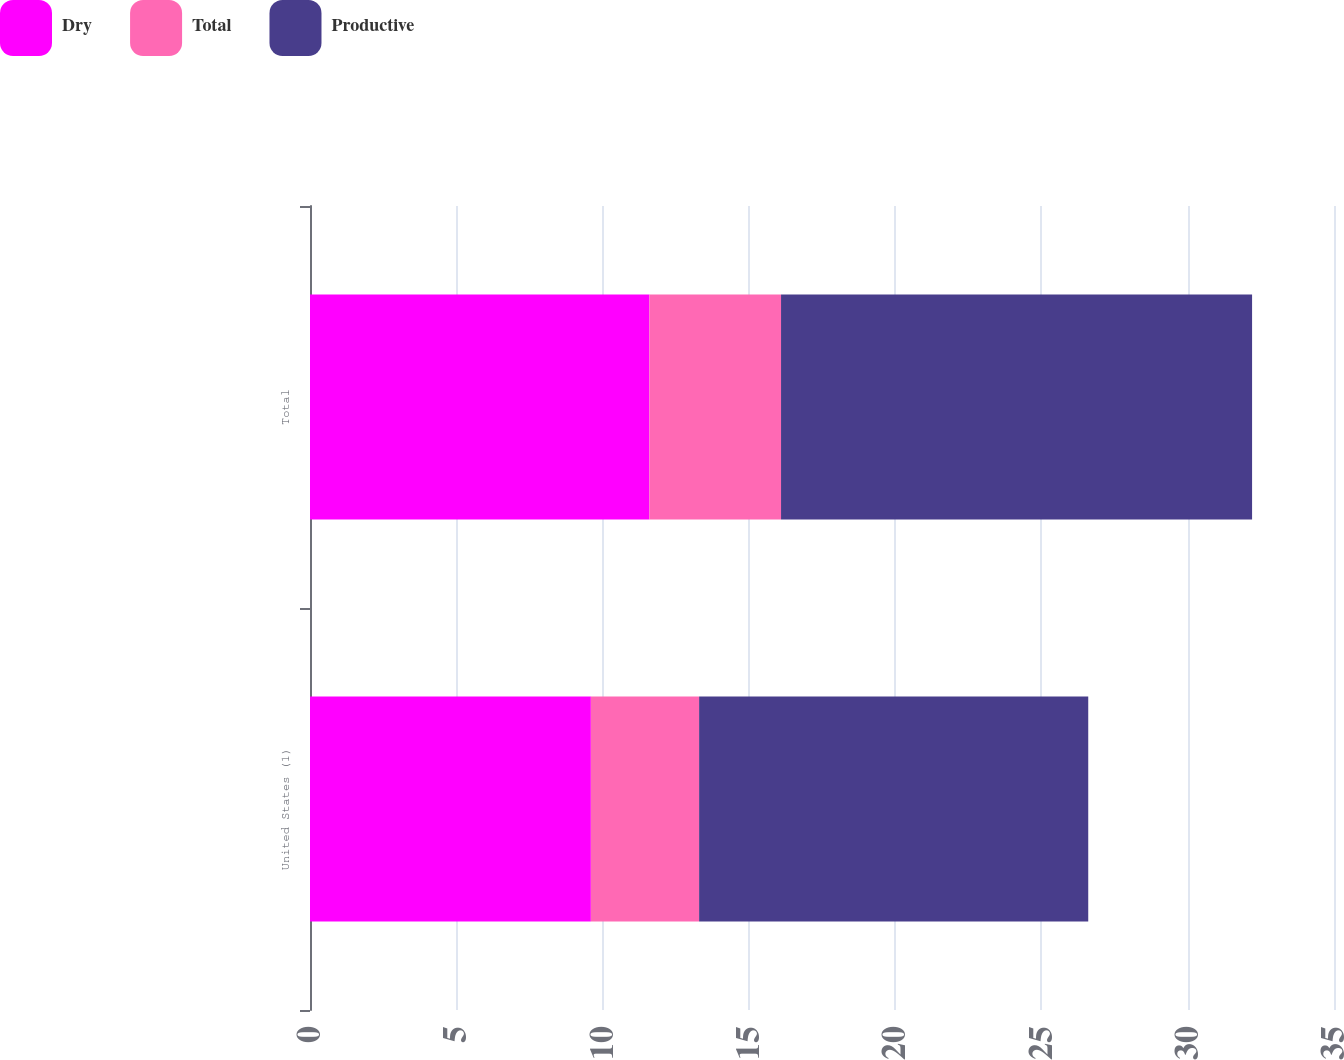Convert chart to OTSL. <chart><loc_0><loc_0><loc_500><loc_500><stacked_bar_chart><ecel><fcel>United States (1)<fcel>Total<nl><fcel>Dry<fcel>9.6<fcel>11.6<nl><fcel>Total<fcel>3.7<fcel>4.5<nl><fcel>Productive<fcel>13.3<fcel>16.1<nl></chart> 